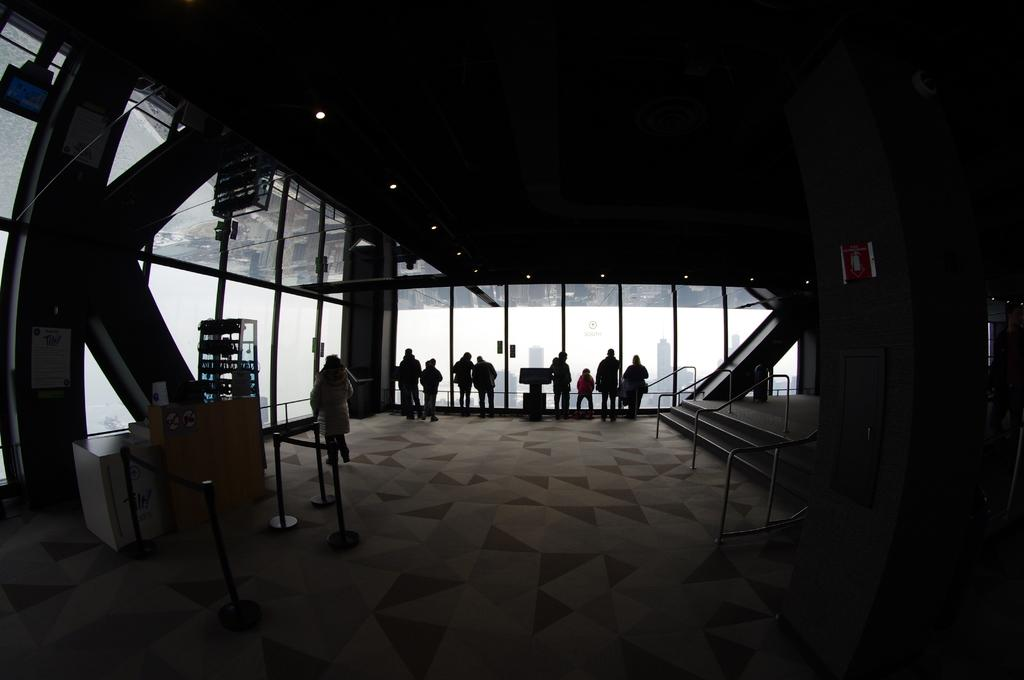How many people are in the image? There is a group of people in the image. What is the surface the people are standing on? The people are standing on the floor. What architectural feature can be seen in the image? There are steps in the image. What can be seen on the walls in the image? There are windows in the image. What is a feature that allows access to the area in the image? There is a door in the image. What provides illumination in the image? There are lights in the image. What other items can be seen in the image besides the people? There are some objects in the image. What type of toys can be seen hanging from the thread in the image? There is no thread or toys present in the image. 